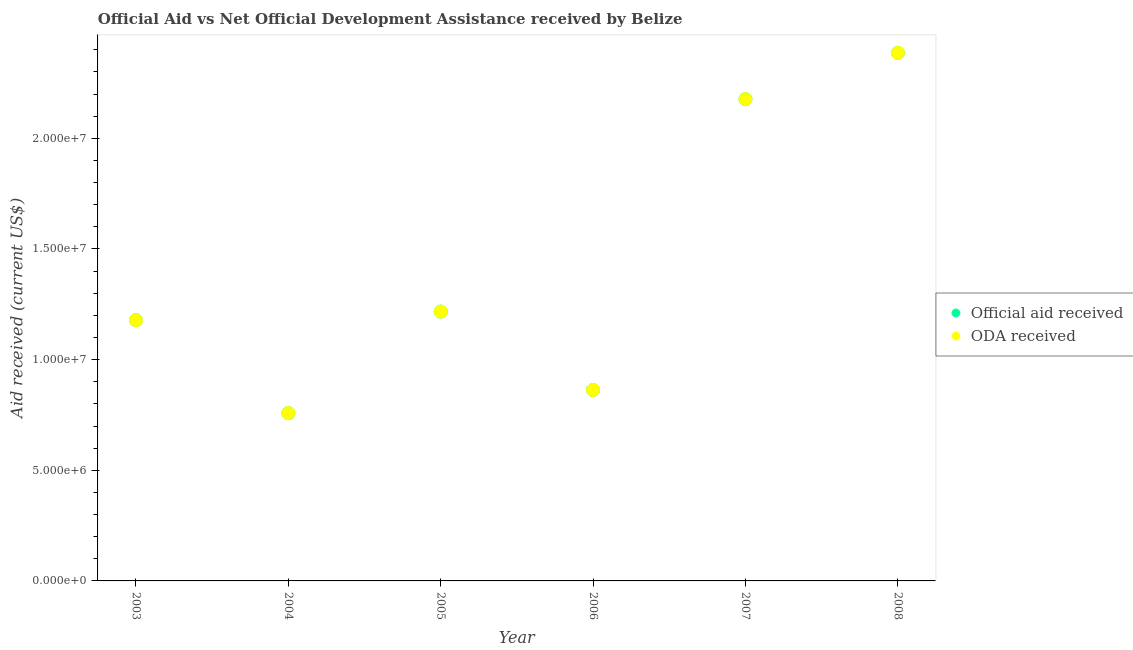How many different coloured dotlines are there?
Offer a very short reply. 2. What is the oda received in 2007?
Ensure brevity in your answer.  2.18e+07. Across all years, what is the maximum official aid received?
Your answer should be compact. 2.39e+07. Across all years, what is the minimum oda received?
Offer a terse response. 7.58e+06. In which year was the oda received maximum?
Keep it short and to the point. 2008. In which year was the oda received minimum?
Ensure brevity in your answer.  2004. What is the total official aid received in the graph?
Your answer should be compact. 8.58e+07. What is the difference between the oda received in 2005 and that in 2006?
Keep it short and to the point. 3.54e+06. What is the difference between the oda received in 2006 and the official aid received in 2005?
Give a very brief answer. -3.54e+06. What is the average official aid received per year?
Your answer should be very brief. 1.43e+07. In the year 2008, what is the difference between the oda received and official aid received?
Make the answer very short. 0. What is the ratio of the official aid received in 2003 to that in 2008?
Make the answer very short. 0.49. Is the official aid received in 2004 less than that in 2006?
Your response must be concise. Yes. What is the difference between the highest and the second highest official aid received?
Keep it short and to the point. 2.09e+06. What is the difference between the highest and the lowest official aid received?
Offer a very short reply. 1.63e+07. Is the sum of the official aid received in 2007 and 2008 greater than the maximum oda received across all years?
Provide a short and direct response. Yes. Does the oda received monotonically increase over the years?
Your answer should be compact. No. Is the oda received strictly less than the official aid received over the years?
Offer a terse response. No. How many dotlines are there?
Give a very brief answer. 2. How many years are there in the graph?
Ensure brevity in your answer.  6. Are the values on the major ticks of Y-axis written in scientific E-notation?
Ensure brevity in your answer.  Yes. Does the graph contain grids?
Offer a terse response. No. Where does the legend appear in the graph?
Your answer should be very brief. Center right. How are the legend labels stacked?
Offer a very short reply. Vertical. What is the title of the graph?
Provide a short and direct response. Official Aid vs Net Official Development Assistance received by Belize . What is the label or title of the Y-axis?
Make the answer very short. Aid received (current US$). What is the Aid received (current US$) of Official aid received in 2003?
Your response must be concise. 1.18e+07. What is the Aid received (current US$) of ODA received in 2003?
Ensure brevity in your answer.  1.18e+07. What is the Aid received (current US$) of Official aid received in 2004?
Offer a very short reply. 7.58e+06. What is the Aid received (current US$) of ODA received in 2004?
Provide a succinct answer. 7.58e+06. What is the Aid received (current US$) of Official aid received in 2005?
Give a very brief answer. 1.22e+07. What is the Aid received (current US$) of ODA received in 2005?
Your response must be concise. 1.22e+07. What is the Aid received (current US$) in Official aid received in 2006?
Your answer should be very brief. 8.63e+06. What is the Aid received (current US$) of ODA received in 2006?
Make the answer very short. 8.63e+06. What is the Aid received (current US$) of Official aid received in 2007?
Provide a succinct answer. 2.18e+07. What is the Aid received (current US$) in ODA received in 2007?
Your answer should be compact. 2.18e+07. What is the Aid received (current US$) of Official aid received in 2008?
Offer a terse response. 2.39e+07. What is the Aid received (current US$) in ODA received in 2008?
Your answer should be very brief. 2.39e+07. Across all years, what is the maximum Aid received (current US$) of Official aid received?
Ensure brevity in your answer.  2.39e+07. Across all years, what is the maximum Aid received (current US$) in ODA received?
Your answer should be compact. 2.39e+07. Across all years, what is the minimum Aid received (current US$) of Official aid received?
Your answer should be very brief. 7.58e+06. Across all years, what is the minimum Aid received (current US$) of ODA received?
Provide a short and direct response. 7.58e+06. What is the total Aid received (current US$) in Official aid received in the graph?
Your answer should be compact. 8.58e+07. What is the total Aid received (current US$) in ODA received in the graph?
Make the answer very short. 8.58e+07. What is the difference between the Aid received (current US$) in Official aid received in 2003 and that in 2004?
Make the answer very short. 4.20e+06. What is the difference between the Aid received (current US$) of ODA received in 2003 and that in 2004?
Keep it short and to the point. 4.20e+06. What is the difference between the Aid received (current US$) of Official aid received in 2003 and that in 2005?
Keep it short and to the point. -3.90e+05. What is the difference between the Aid received (current US$) in ODA received in 2003 and that in 2005?
Your response must be concise. -3.90e+05. What is the difference between the Aid received (current US$) in Official aid received in 2003 and that in 2006?
Your response must be concise. 3.15e+06. What is the difference between the Aid received (current US$) in ODA received in 2003 and that in 2006?
Ensure brevity in your answer.  3.15e+06. What is the difference between the Aid received (current US$) of Official aid received in 2003 and that in 2007?
Ensure brevity in your answer.  -9.99e+06. What is the difference between the Aid received (current US$) of ODA received in 2003 and that in 2007?
Your response must be concise. -9.99e+06. What is the difference between the Aid received (current US$) of Official aid received in 2003 and that in 2008?
Your response must be concise. -1.21e+07. What is the difference between the Aid received (current US$) in ODA received in 2003 and that in 2008?
Offer a very short reply. -1.21e+07. What is the difference between the Aid received (current US$) of Official aid received in 2004 and that in 2005?
Provide a short and direct response. -4.59e+06. What is the difference between the Aid received (current US$) in ODA received in 2004 and that in 2005?
Offer a very short reply. -4.59e+06. What is the difference between the Aid received (current US$) of Official aid received in 2004 and that in 2006?
Give a very brief answer. -1.05e+06. What is the difference between the Aid received (current US$) in ODA received in 2004 and that in 2006?
Offer a terse response. -1.05e+06. What is the difference between the Aid received (current US$) in Official aid received in 2004 and that in 2007?
Keep it short and to the point. -1.42e+07. What is the difference between the Aid received (current US$) in ODA received in 2004 and that in 2007?
Provide a succinct answer. -1.42e+07. What is the difference between the Aid received (current US$) in Official aid received in 2004 and that in 2008?
Provide a succinct answer. -1.63e+07. What is the difference between the Aid received (current US$) of ODA received in 2004 and that in 2008?
Give a very brief answer. -1.63e+07. What is the difference between the Aid received (current US$) in Official aid received in 2005 and that in 2006?
Give a very brief answer. 3.54e+06. What is the difference between the Aid received (current US$) in ODA received in 2005 and that in 2006?
Your answer should be very brief. 3.54e+06. What is the difference between the Aid received (current US$) in Official aid received in 2005 and that in 2007?
Your response must be concise. -9.60e+06. What is the difference between the Aid received (current US$) in ODA received in 2005 and that in 2007?
Your answer should be very brief. -9.60e+06. What is the difference between the Aid received (current US$) of Official aid received in 2005 and that in 2008?
Offer a terse response. -1.17e+07. What is the difference between the Aid received (current US$) of ODA received in 2005 and that in 2008?
Your response must be concise. -1.17e+07. What is the difference between the Aid received (current US$) of Official aid received in 2006 and that in 2007?
Make the answer very short. -1.31e+07. What is the difference between the Aid received (current US$) in ODA received in 2006 and that in 2007?
Make the answer very short. -1.31e+07. What is the difference between the Aid received (current US$) of Official aid received in 2006 and that in 2008?
Make the answer very short. -1.52e+07. What is the difference between the Aid received (current US$) of ODA received in 2006 and that in 2008?
Provide a succinct answer. -1.52e+07. What is the difference between the Aid received (current US$) in Official aid received in 2007 and that in 2008?
Offer a terse response. -2.09e+06. What is the difference between the Aid received (current US$) in ODA received in 2007 and that in 2008?
Your response must be concise. -2.09e+06. What is the difference between the Aid received (current US$) of Official aid received in 2003 and the Aid received (current US$) of ODA received in 2004?
Give a very brief answer. 4.20e+06. What is the difference between the Aid received (current US$) of Official aid received in 2003 and the Aid received (current US$) of ODA received in 2005?
Your answer should be very brief. -3.90e+05. What is the difference between the Aid received (current US$) of Official aid received in 2003 and the Aid received (current US$) of ODA received in 2006?
Your answer should be very brief. 3.15e+06. What is the difference between the Aid received (current US$) in Official aid received in 2003 and the Aid received (current US$) in ODA received in 2007?
Your response must be concise. -9.99e+06. What is the difference between the Aid received (current US$) in Official aid received in 2003 and the Aid received (current US$) in ODA received in 2008?
Your answer should be very brief. -1.21e+07. What is the difference between the Aid received (current US$) in Official aid received in 2004 and the Aid received (current US$) in ODA received in 2005?
Your answer should be compact. -4.59e+06. What is the difference between the Aid received (current US$) of Official aid received in 2004 and the Aid received (current US$) of ODA received in 2006?
Keep it short and to the point. -1.05e+06. What is the difference between the Aid received (current US$) of Official aid received in 2004 and the Aid received (current US$) of ODA received in 2007?
Give a very brief answer. -1.42e+07. What is the difference between the Aid received (current US$) in Official aid received in 2004 and the Aid received (current US$) in ODA received in 2008?
Ensure brevity in your answer.  -1.63e+07. What is the difference between the Aid received (current US$) of Official aid received in 2005 and the Aid received (current US$) of ODA received in 2006?
Provide a short and direct response. 3.54e+06. What is the difference between the Aid received (current US$) in Official aid received in 2005 and the Aid received (current US$) in ODA received in 2007?
Provide a succinct answer. -9.60e+06. What is the difference between the Aid received (current US$) of Official aid received in 2005 and the Aid received (current US$) of ODA received in 2008?
Make the answer very short. -1.17e+07. What is the difference between the Aid received (current US$) in Official aid received in 2006 and the Aid received (current US$) in ODA received in 2007?
Your response must be concise. -1.31e+07. What is the difference between the Aid received (current US$) of Official aid received in 2006 and the Aid received (current US$) of ODA received in 2008?
Ensure brevity in your answer.  -1.52e+07. What is the difference between the Aid received (current US$) of Official aid received in 2007 and the Aid received (current US$) of ODA received in 2008?
Provide a short and direct response. -2.09e+06. What is the average Aid received (current US$) in Official aid received per year?
Offer a terse response. 1.43e+07. What is the average Aid received (current US$) of ODA received per year?
Provide a succinct answer. 1.43e+07. In the year 2007, what is the difference between the Aid received (current US$) of Official aid received and Aid received (current US$) of ODA received?
Your response must be concise. 0. In the year 2008, what is the difference between the Aid received (current US$) in Official aid received and Aid received (current US$) in ODA received?
Your answer should be very brief. 0. What is the ratio of the Aid received (current US$) of Official aid received in 2003 to that in 2004?
Your answer should be very brief. 1.55. What is the ratio of the Aid received (current US$) in ODA received in 2003 to that in 2004?
Make the answer very short. 1.55. What is the ratio of the Aid received (current US$) of Official aid received in 2003 to that in 2005?
Provide a succinct answer. 0.97. What is the ratio of the Aid received (current US$) in ODA received in 2003 to that in 2005?
Make the answer very short. 0.97. What is the ratio of the Aid received (current US$) in Official aid received in 2003 to that in 2006?
Offer a terse response. 1.36. What is the ratio of the Aid received (current US$) of ODA received in 2003 to that in 2006?
Provide a succinct answer. 1.36. What is the ratio of the Aid received (current US$) in Official aid received in 2003 to that in 2007?
Ensure brevity in your answer.  0.54. What is the ratio of the Aid received (current US$) of ODA received in 2003 to that in 2007?
Give a very brief answer. 0.54. What is the ratio of the Aid received (current US$) of Official aid received in 2003 to that in 2008?
Ensure brevity in your answer.  0.49. What is the ratio of the Aid received (current US$) in ODA received in 2003 to that in 2008?
Give a very brief answer. 0.49. What is the ratio of the Aid received (current US$) of Official aid received in 2004 to that in 2005?
Give a very brief answer. 0.62. What is the ratio of the Aid received (current US$) in ODA received in 2004 to that in 2005?
Your response must be concise. 0.62. What is the ratio of the Aid received (current US$) in Official aid received in 2004 to that in 2006?
Your response must be concise. 0.88. What is the ratio of the Aid received (current US$) of ODA received in 2004 to that in 2006?
Offer a terse response. 0.88. What is the ratio of the Aid received (current US$) in Official aid received in 2004 to that in 2007?
Keep it short and to the point. 0.35. What is the ratio of the Aid received (current US$) in ODA received in 2004 to that in 2007?
Your answer should be compact. 0.35. What is the ratio of the Aid received (current US$) in Official aid received in 2004 to that in 2008?
Provide a succinct answer. 0.32. What is the ratio of the Aid received (current US$) in ODA received in 2004 to that in 2008?
Your answer should be compact. 0.32. What is the ratio of the Aid received (current US$) in Official aid received in 2005 to that in 2006?
Provide a succinct answer. 1.41. What is the ratio of the Aid received (current US$) of ODA received in 2005 to that in 2006?
Give a very brief answer. 1.41. What is the ratio of the Aid received (current US$) of Official aid received in 2005 to that in 2007?
Your response must be concise. 0.56. What is the ratio of the Aid received (current US$) in ODA received in 2005 to that in 2007?
Provide a succinct answer. 0.56. What is the ratio of the Aid received (current US$) of Official aid received in 2005 to that in 2008?
Provide a short and direct response. 0.51. What is the ratio of the Aid received (current US$) in ODA received in 2005 to that in 2008?
Your answer should be compact. 0.51. What is the ratio of the Aid received (current US$) of Official aid received in 2006 to that in 2007?
Provide a short and direct response. 0.4. What is the ratio of the Aid received (current US$) of ODA received in 2006 to that in 2007?
Provide a short and direct response. 0.4. What is the ratio of the Aid received (current US$) of Official aid received in 2006 to that in 2008?
Offer a very short reply. 0.36. What is the ratio of the Aid received (current US$) of ODA received in 2006 to that in 2008?
Keep it short and to the point. 0.36. What is the ratio of the Aid received (current US$) in Official aid received in 2007 to that in 2008?
Your answer should be very brief. 0.91. What is the ratio of the Aid received (current US$) in ODA received in 2007 to that in 2008?
Your answer should be very brief. 0.91. What is the difference between the highest and the second highest Aid received (current US$) in Official aid received?
Your response must be concise. 2.09e+06. What is the difference between the highest and the second highest Aid received (current US$) of ODA received?
Your response must be concise. 2.09e+06. What is the difference between the highest and the lowest Aid received (current US$) in Official aid received?
Provide a succinct answer. 1.63e+07. What is the difference between the highest and the lowest Aid received (current US$) of ODA received?
Offer a terse response. 1.63e+07. 